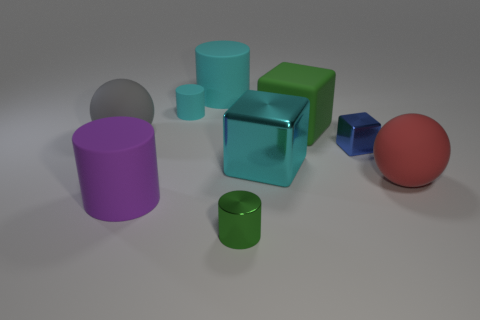There is a block that is the same color as the small rubber object; what material is it?
Your answer should be compact. Metal. There is a green matte object that is the same shape as the small blue shiny object; what is its size?
Ensure brevity in your answer.  Large. There is a blue object; does it have the same shape as the big cyan thing in front of the large cyan rubber cylinder?
Ensure brevity in your answer.  Yes. What is the size of the rubber ball left of the large rubber cylinder in front of the gray sphere?
Offer a terse response. Large. Are there the same number of rubber blocks left of the large shiny block and cylinders that are right of the big cyan rubber object?
Your response must be concise. No. What color is the tiny thing that is the same shape as the big cyan metal object?
Provide a succinct answer. Blue. How many small objects are the same color as the rubber block?
Give a very brief answer. 1. Is the shape of the tiny metallic object that is left of the tiny blue metallic object the same as  the cyan metal object?
Offer a very short reply. No. What is the shape of the cyan rubber thing that is behind the small cylinder behind the big sphere left of the tiny green cylinder?
Give a very brief answer. Cylinder. What size is the cyan metal thing?
Offer a terse response. Large. 